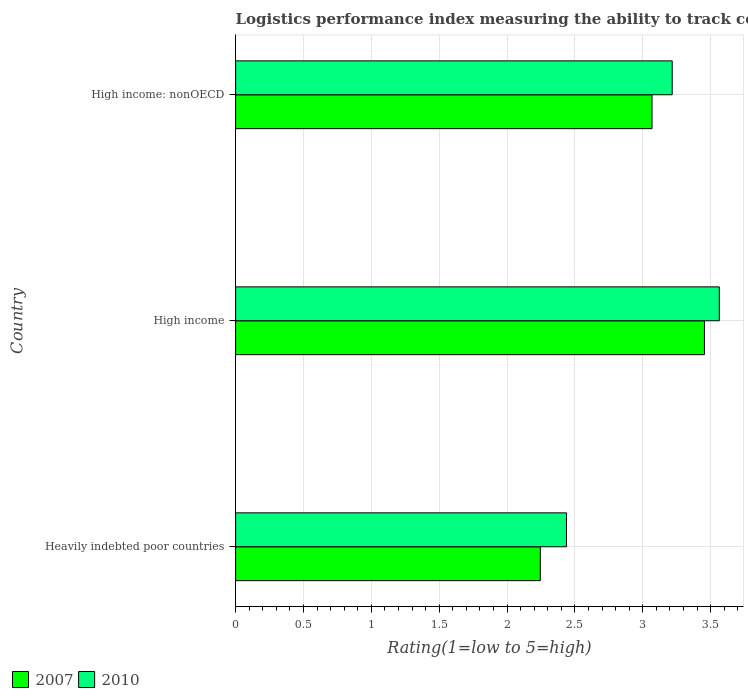Are the number of bars per tick equal to the number of legend labels?
Provide a succinct answer. Yes. How many bars are there on the 2nd tick from the top?
Keep it short and to the point. 2. How many bars are there on the 3rd tick from the bottom?
Provide a succinct answer. 2. What is the label of the 1st group of bars from the top?
Give a very brief answer. High income: nonOECD. In how many cases, is the number of bars for a given country not equal to the number of legend labels?
Make the answer very short. 0. What is the Logistic performance index in 2007 in High income: nonOECD?
Your answer should be compact. 3.07. Across all countries, what is the maximum Logistic performance index in 2007?
Make the answer very short. 3.45. Across all countries, what is the minimum Logistic performance index in 2010?
Make the answer very short. 2.44. In which country was the Logistic performance index in 2010 maximum?
Make the answer very short. High income. In which country was the Logistic performance index in 2010 minimum?
Your answer should be very brief. Heavily indebted poor countries. What is the total Logistic performance index in 2010 in the graph?
Your answer should be very brief. 9.22. What is the difference between the Logistic performance index in 2010 in Heavily indebted poor countries and that in High income?
Ensure brevity in your answer.  -1.13. What is the difference between the Logistic performance index in 2010 in Heavily indebted poor countries and the Logistic performance index in 2007 in High income: nonOECD?
Offer a very short reply. -0.63. What is the average Logistic performance index in 2007 per country?
Provide a short and direct response. 2.92. What is the difference between the Logistic performance index in 2010 and Logistic performance index in 2007 in Heavily indebted poor countries?
Offer a terse response. 0.19. In how many countries, is the Logistic performance index in 2007 greater than 1.3 ?
Your answer should be compact. 3. What is the ratio of the Logistic performance index in 2007 in Heavily indebted poor countries to that in High income: nonOECD?
Ensure brevity in your answer.  0.73. Is the Logistic performance index in 2010 in High income less than that in High income: nonOECD?
Your response must be concise. No. Is the difference between the Logistic performance index in 2010 in High income and High income: nonOECD greater than the difference between the Logistic performance index in 2007 in High income and High income: nonOECD?
Your answer should be very brief. No. What is the difference between the highest and the second highest Logistic performance index in 2010?
Offer a terse response. 0.35. What is the difference between the highest and the lowest Logistic performance index in 2010?
Offer a very short reply. 1.13. In how many countries, is the Logistic performance index in 2007 greater than the average Logistic performance index in 2007 taken over all countries?
Your response must be concise. 2. What does the 2nd bar from the top in High income represents?
Make the answer very short. 2007. What does the 2nd bar from the bottom in High income: nonOECD represents?
Your response must be concise. 2010. Are all the bars in the graph horizontal?
Provide a short and direct response. Yes. Does the graph contain grids?
Your answer should be very brief. Yes. Where does the legend appear in the graph?
Provide a succinct answer. Bottom left. How are the legend labels stacked?
Offer a terse response. Horizontal. What is the title of the graph?
Ensure brevity in your answer.  Logistics performance index measuring the ability to track consignments when shipping to a market. Does "2011" appear as one of the legend labels in the graph?
Provide a succinct answer. No. What is the label or title of the X-axis?
Offer a very short reply. Rating(1=low to 5=high). What is the label or title of the Y-axis?
Give a very brief answer. Country. What is the Rating(1=low to 5=high) of 2007 in Heavily indebted poor countries?
Make the answer very short. 2.25. What is the Rating(1=low to 5=high) of 2010 in Heavily indebted poor countries?
Ensure brevity in your answer.  2.44. What is the Rating(1=low to 5=high) of 2007 in High income?
Offer a terse response. 3.45. What is the Rating(1=low to 5=high) in 2010 in High income?
Offer a terse response. 3.56. What is the Rating(1=low to 5=high) in 2007 in High income: nonOECD?
Give a very brief answer. 3.07. What is the Rating(1=low to 5=high) in 2010 in High income: nonOECD?
Your response must be concise. 3.22. Across all countries, what is the maximum Rating(1=low to 5=high) in 2007?
Make the answer very short. 3.45. Across all countries, what is the maximum Rating(1=low to 5=high) in 2010?
Keep it short and to the point. 3.56. Across all countries, what is the minimum Rating(1=low to 5=high) in 2007?
Your answer should be compact. 2.25. Across all countries, what is the minimum Rating(1=low to 5=high) in 2010?
Your answer should be very brief. 2.44. What is the total Rating(1=low to 5=high) of 2007 in the graph?
Provide a succinct answer. 8.77. What is the total Rating(1=low to 5=high) of 2010 in the graph?
Provide a succinct answer. 9.22. What is the difference between the Rating(1=low to 5=high) of 2007 in Heavily indebted poor countries and that in High income?
Offer a terse response. -1.21. What is the difference between the Rating(1=low to 5=high) in 2010 in Heavily indebted poor countries and that in High income?
Give a very brief answer. -1.13. What is the difference between the Rating(1=low to 5=high) of 2007 in Heavily indebted poor countries and that in High income: nonOECD?
Provide a short and direct response. -0.82. What is the difference between the Rating(1=low to 5=high) of 2010 in Heavily indebted poor countries and that in High income: nonOECD?
Offer a very short reply. -0.78. What is the difference between the Rating(1=low to 5=high) of 2007 in High income and that in High income: nonOECD?
Offer a very short reply. 0.39. What is the difference between the Rating(1=low to 5=high) in 2010 in High income and that in High income: nonOECD?
Offer a very short reply. 0.35. What is the difference between the Rating(1=low to 5=high) in 2007 in Heavily indebted poor countries and the Rating(1=low to 5=high) in 2010 in High income?
Offer a terse response. -1.32. What is the difference between the Rating(1=low to 5=high) of 2007 in Heavily indebted poor countries and the Rating(1=low to 5=high) of 2010 in High income: nonOECD?
Provide a succinct answer. -0.97. What is the difference between the Rating(1=low to 5=high) of 2007 in High income and the Rating(1=low to 5=high) of 2010 in High income: nonOECD?
Make the answer very short. 0.24. What is the average Rating(1=low to 5=high) in 2007 per country?
Offer a very short reply. 2.92. What is the average Rating(1=low to 5=high) in 2010 per country?
Keep it short and to the point. 3.07. What is the difference between the Rating(1=low to 5=high) of 2007 and Rating(1=low to 5=high) of 2010 in Heavily indebted poor countries?
Provide a succinct answer. -0.19. What is the difference between the Rating(1=low to 5=high) in 2007 and Rating(1=low to 5=high) in 2010 in High income?
Your answer should be compact. -0.11. What is the difference between the Rating(1=low to 5=high) in 2007 and Rating(1=low to 5=high) in 2010 in High income: nonOECD?
Your answer should be very brief. -0.15. What is the ratio of the Rating(1=low to 5=high) in 2007 in Heavily indebted poor countries to that in High income?
Ensure brevity in your answer.  0.65. What is the ratio of the Rating(1=low to 5=high) of 2010 in Heavily indebted poor countries to that in High income?
Offer a terse response. 0.68. What is the ratio of the Rating(1=low to 5=high) in 2007 in Heavily indebted poor countries to that in High income: nonOECD?
Your response must be concise. 0.73. What is the ratio of the Rating(1=low to 5=high) in 2010 in Heavily indebted poor countries to that in High income: nonOECD?
Your response must be concise. 0.76. What is the ratio of the Rating(1=low to 5=high) in 2007 in High income to that in High income: nonOECD?
Your answer should be compact. 1.13. What is the ratio of the Rating(1=low to 5=high) in 2010 in High income to that in High income: nonOECD?
Ensure brevity in your answer.  1.11. What is the difference between the highest and the second highest Rating(1=low to 5=high) of 2007?
Your response must be concise. 0.39. What is the difference between the highest and the second highest Rating(1=low to 5=high) in 2010?
Provide a short and direct response. 0.35. What is the difference between the highest and the lowest Rating(1=low to 5=high) in 2007?
Make the answer very short. 1.21. What is the difference between the highest and the lowest Rating(1=low to 5=high) of 2010?
Offer a very short reply. 1.13. 